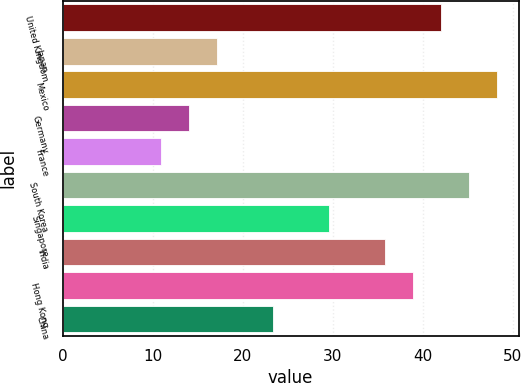Convert chart to OTSL. <chart><loc_0><loc_0><loc_500><loc_500><bar_chart><fcel>United Kingdom<fcel>Japan<fcel>Mexico<fcel>Germany<fcel>France<fcel>South Korea<fcel>Singapore<fcel>India<fcel>Hong Kong<fcel>China<nl><fcel>42.02<fcel>17.14<fcel>48.24<fcel>14.03<fcel>10.92<fcel>45.13<fcel>29.58<fcel>35.8<fcel>38.91<fcel>23.36<nl></chart> 